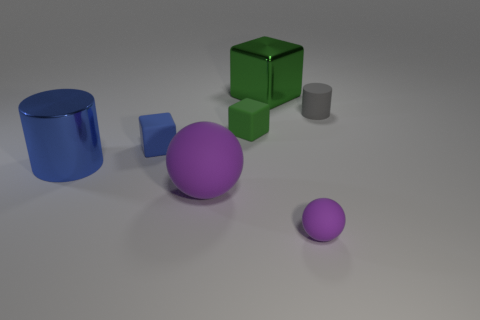Add 3 small yellow balls. How many objects exist? 10 Subtract all blocks. How many objects are left? 4 Add 7 metallic blocks. How many metallic blocks are left? 8 Add 6 big green blocks. How many big green blocks exist? 7 Subtract 1 blue cylinders. How many objects are left? 6 Subtract all metal cubes. Subtract all big metal objects. How many objects are left? 4 